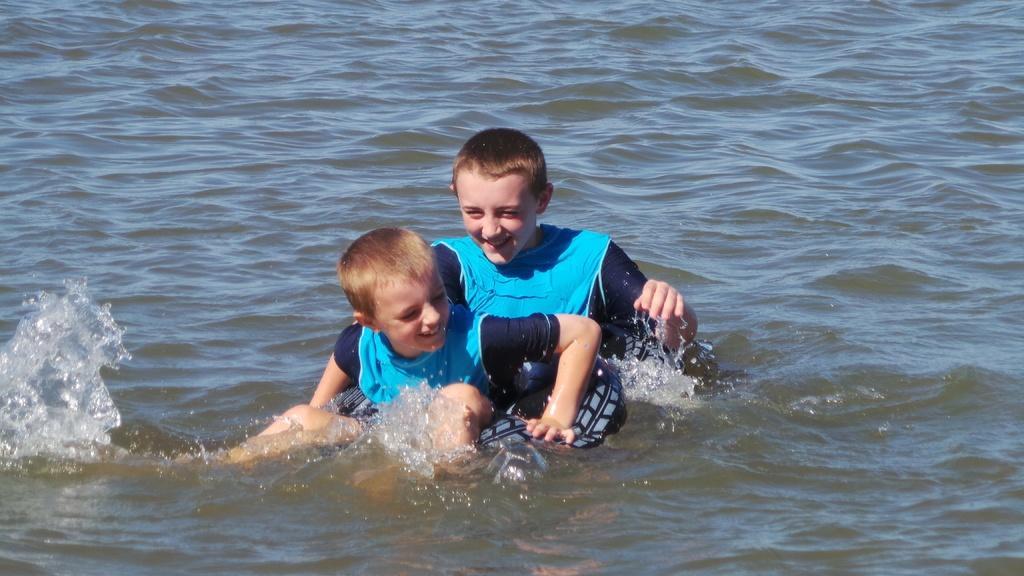In one or two sentences, can you explain what this image depicts? In the center of the image we can see kids playing in the water. 